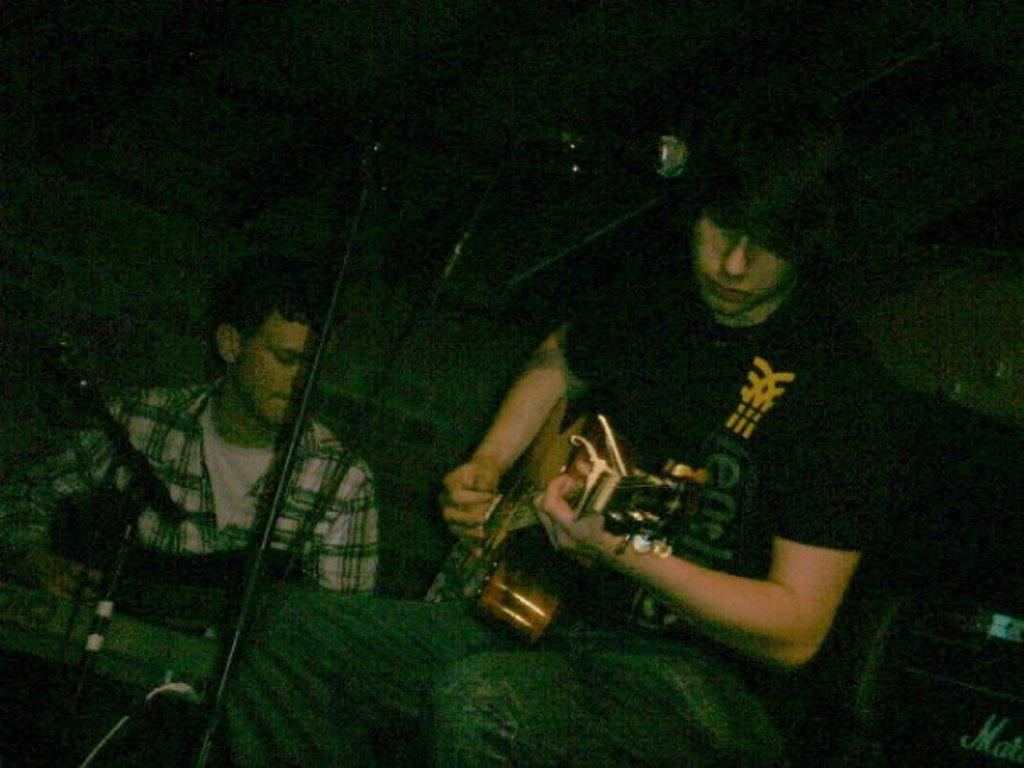How many people are in the image? There are two persons in the image. What are the two persons doing in the image? Both persons are playing musical instruments. What type of cabbage is being served for dinner in the image? There is no reference to dinner or cabbage in the image; it features two persons playing musical instruments. 